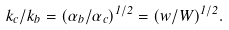<formula> <loc_0><loc_0><loc_500><loc_500>k _ { c } / k _ { b } = ( \alpha _ { b } / \alpha _ { c } ) ^ { 1 / 2 } = ( w / W ) ^ { 1 / 2 } .</formula> 